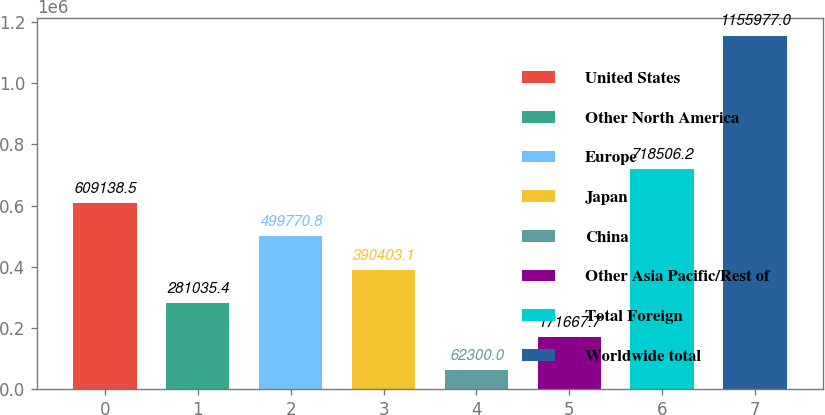<chart> <loc_0><loc_0><loc_500><loc_500><bar_chart><fcel>United States<fcel>Other North America<fcel>Europe<fcel>Japan<fcel>China<fcel>Other Asia Pacific/Rest of<fcel>Total Foreign<fcel>Worldwide total<nl><fcel>609138<fcel>281035<fcel>499771<fcel>390403<fcel>62300<fcel>171668<fcel>718506<fcel>1.15598e+06<nl></chart> 